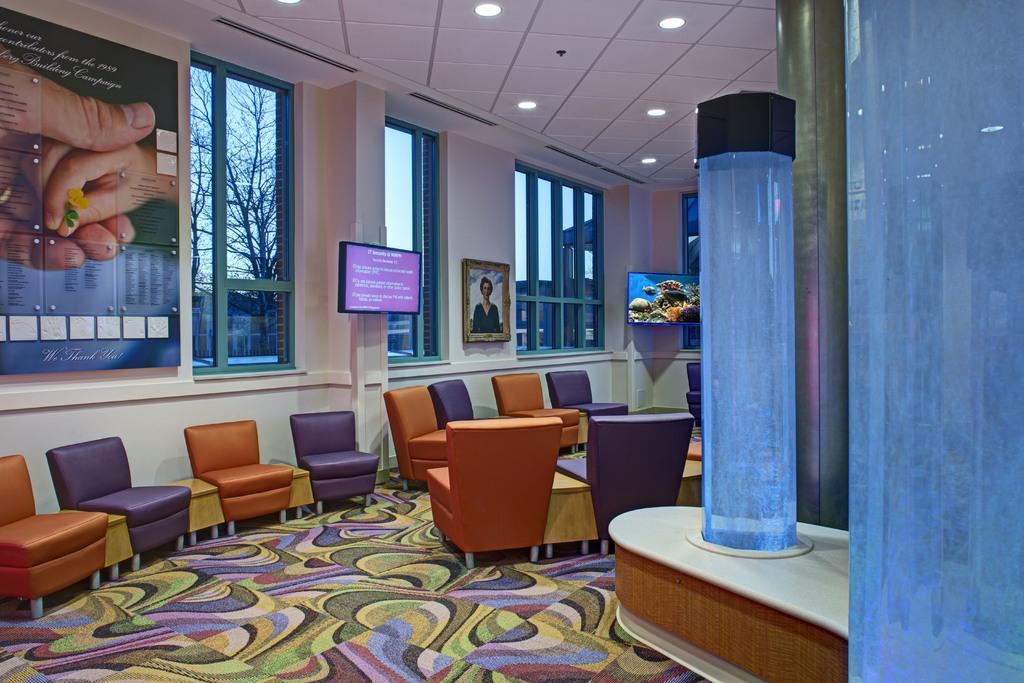In one or two sentences, can you explain what this image depicts? In this image there is a room in which there are so many chairs on the floor. On the left side there are windows. At the top there is ceiling with the lights. On the left side top there is a poster which is fixed to the wall. In the background there is an aquarium. To the wall there is a photo frame. On the floor there is a design. On the right side there is a glass item. 